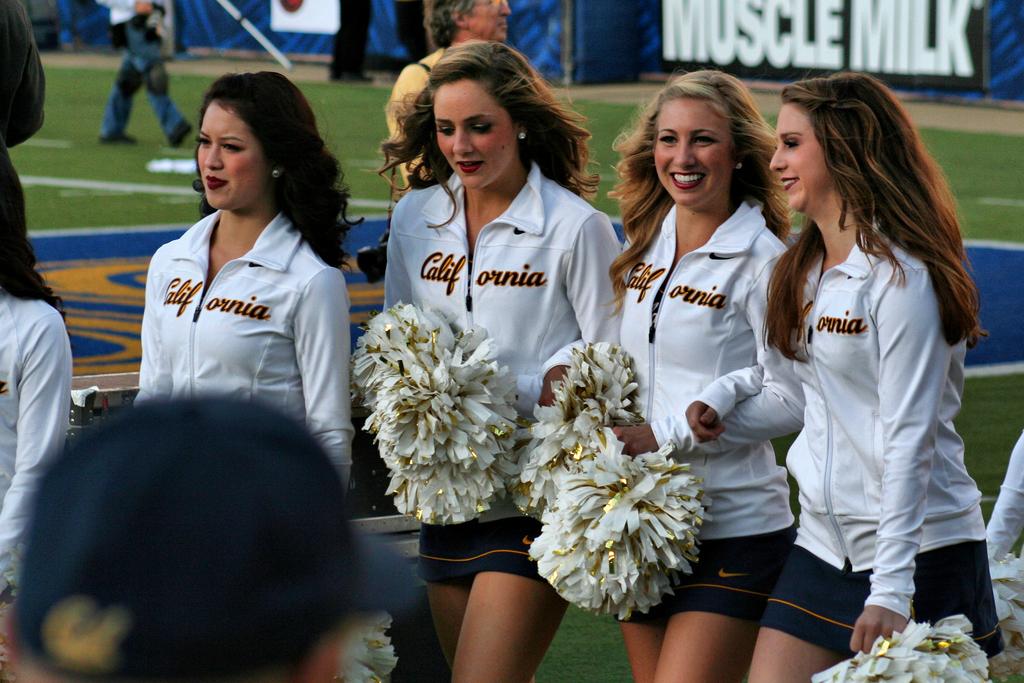Who are these ladies cheering for?
Provide a short and direct response. California. What brand is that on the billboard in the background?
Your answer should be very brief. Muscle milk. 